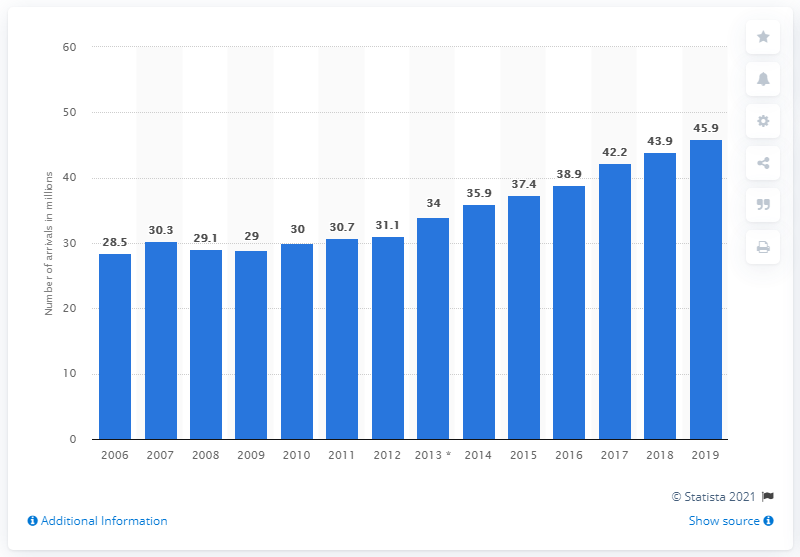Draw attention to some important aspects in this diagram. The number of tourist arrivals in short-stay accommodation in the Netherlands has been increasing since 2009. In 2019, the highest number of tourist arrivals in travel accommodation in the Netherlands was 45.9 million. 